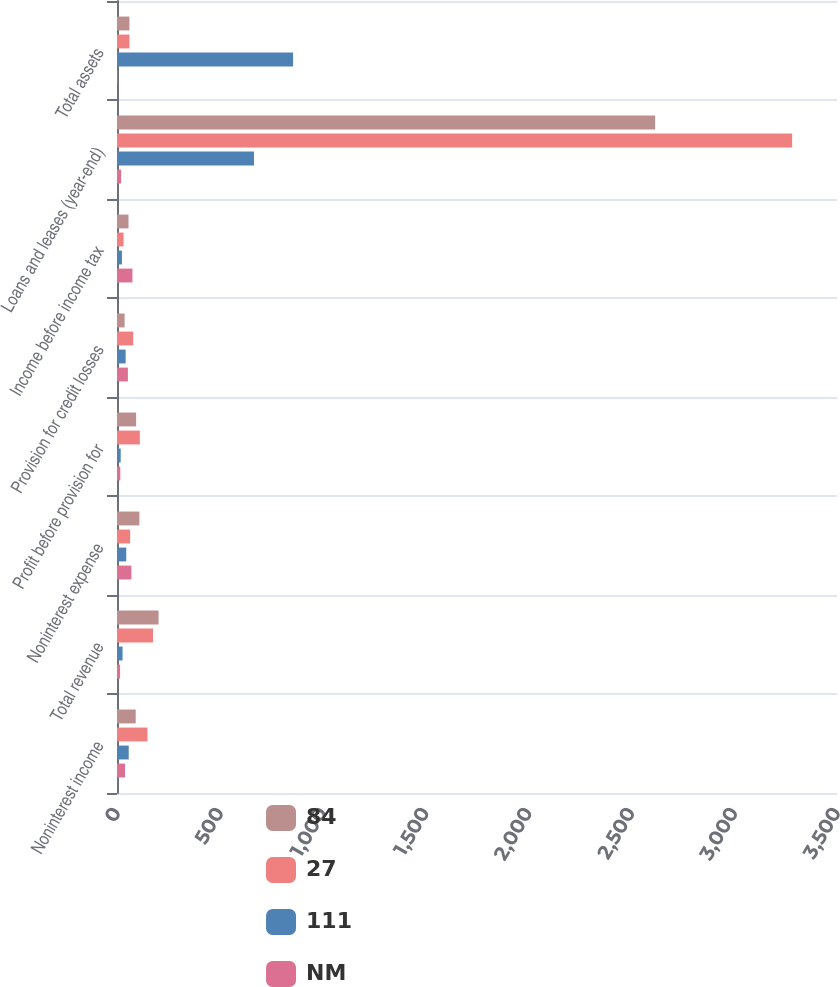<chart> <loc_0><loc_0><loc_500><loc_500><stacked_bar_chart><ecel><fcel>Noninterest income<fcel>Total revenue<fcel>Noninterest expense<fcel>Profit before provision for<fcel>Provision for credit losses<fcel>Income before income tax<fcel>Loans and leases (year-end)<fcel>Total assets<nl><fcel>84<fcel>91<fcel>202<fcel>109<fcel>93<fcel>37<fcel>56<fcel>2616<fcel>60.5<nl><fcel>27<fcel>148<fcel>175<fcel>64<fcel>111<fcel>79<fcel>32<fcel>3282<fcel>60.5<nl><fcel>111<fcel>57<fcel>27<fcel>45<fcel>18<fcel>42<fcel>24<fcel>666<fcel>856<nl><fcel>NM<fcel>39<fcel>15<fcel>70<fcel>16<fcel>53<fcel>75<fcel>20<fcel>2<nl></chart> 